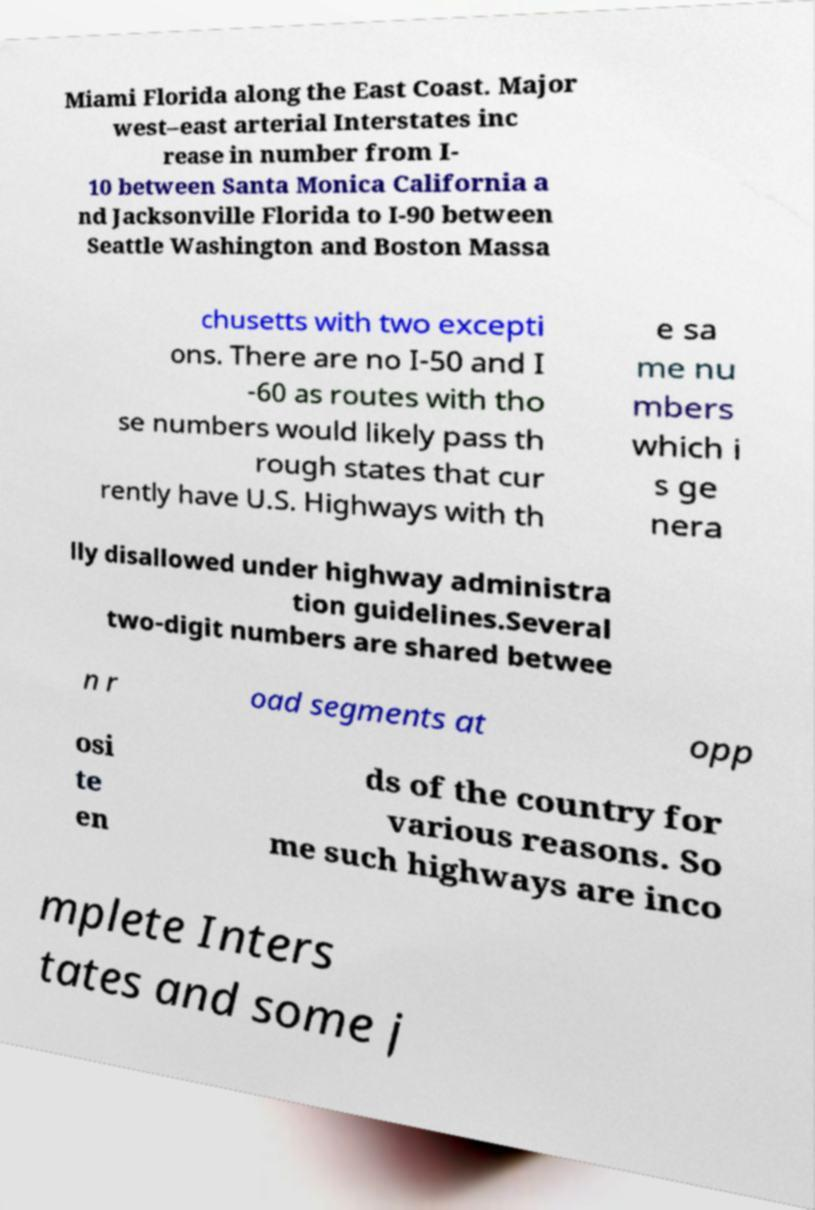I need the written content from this picture converted into text. Can you do that? Miami Florida along the East Coast. Major west–east arterial Interstates inc rease in number from I- 10 between Santa Monica California a nd Jacksonville Florida to I-90 between Seattle Washington and Boston Massa chusetts with two excepti ons. There are no I-50 and I -60 as routes with tho se numbers would likely pass th rough states that cur rently have U.S. Highways with th e sa me nu mbers which i s ge nera lly disallowed under highway administra tion guidelines.Several two-digit numbers are shared betwee n r oad segments at opp osi te en ds of the country for various reasons. So me such highways are inco mplete Inters tates and some j 